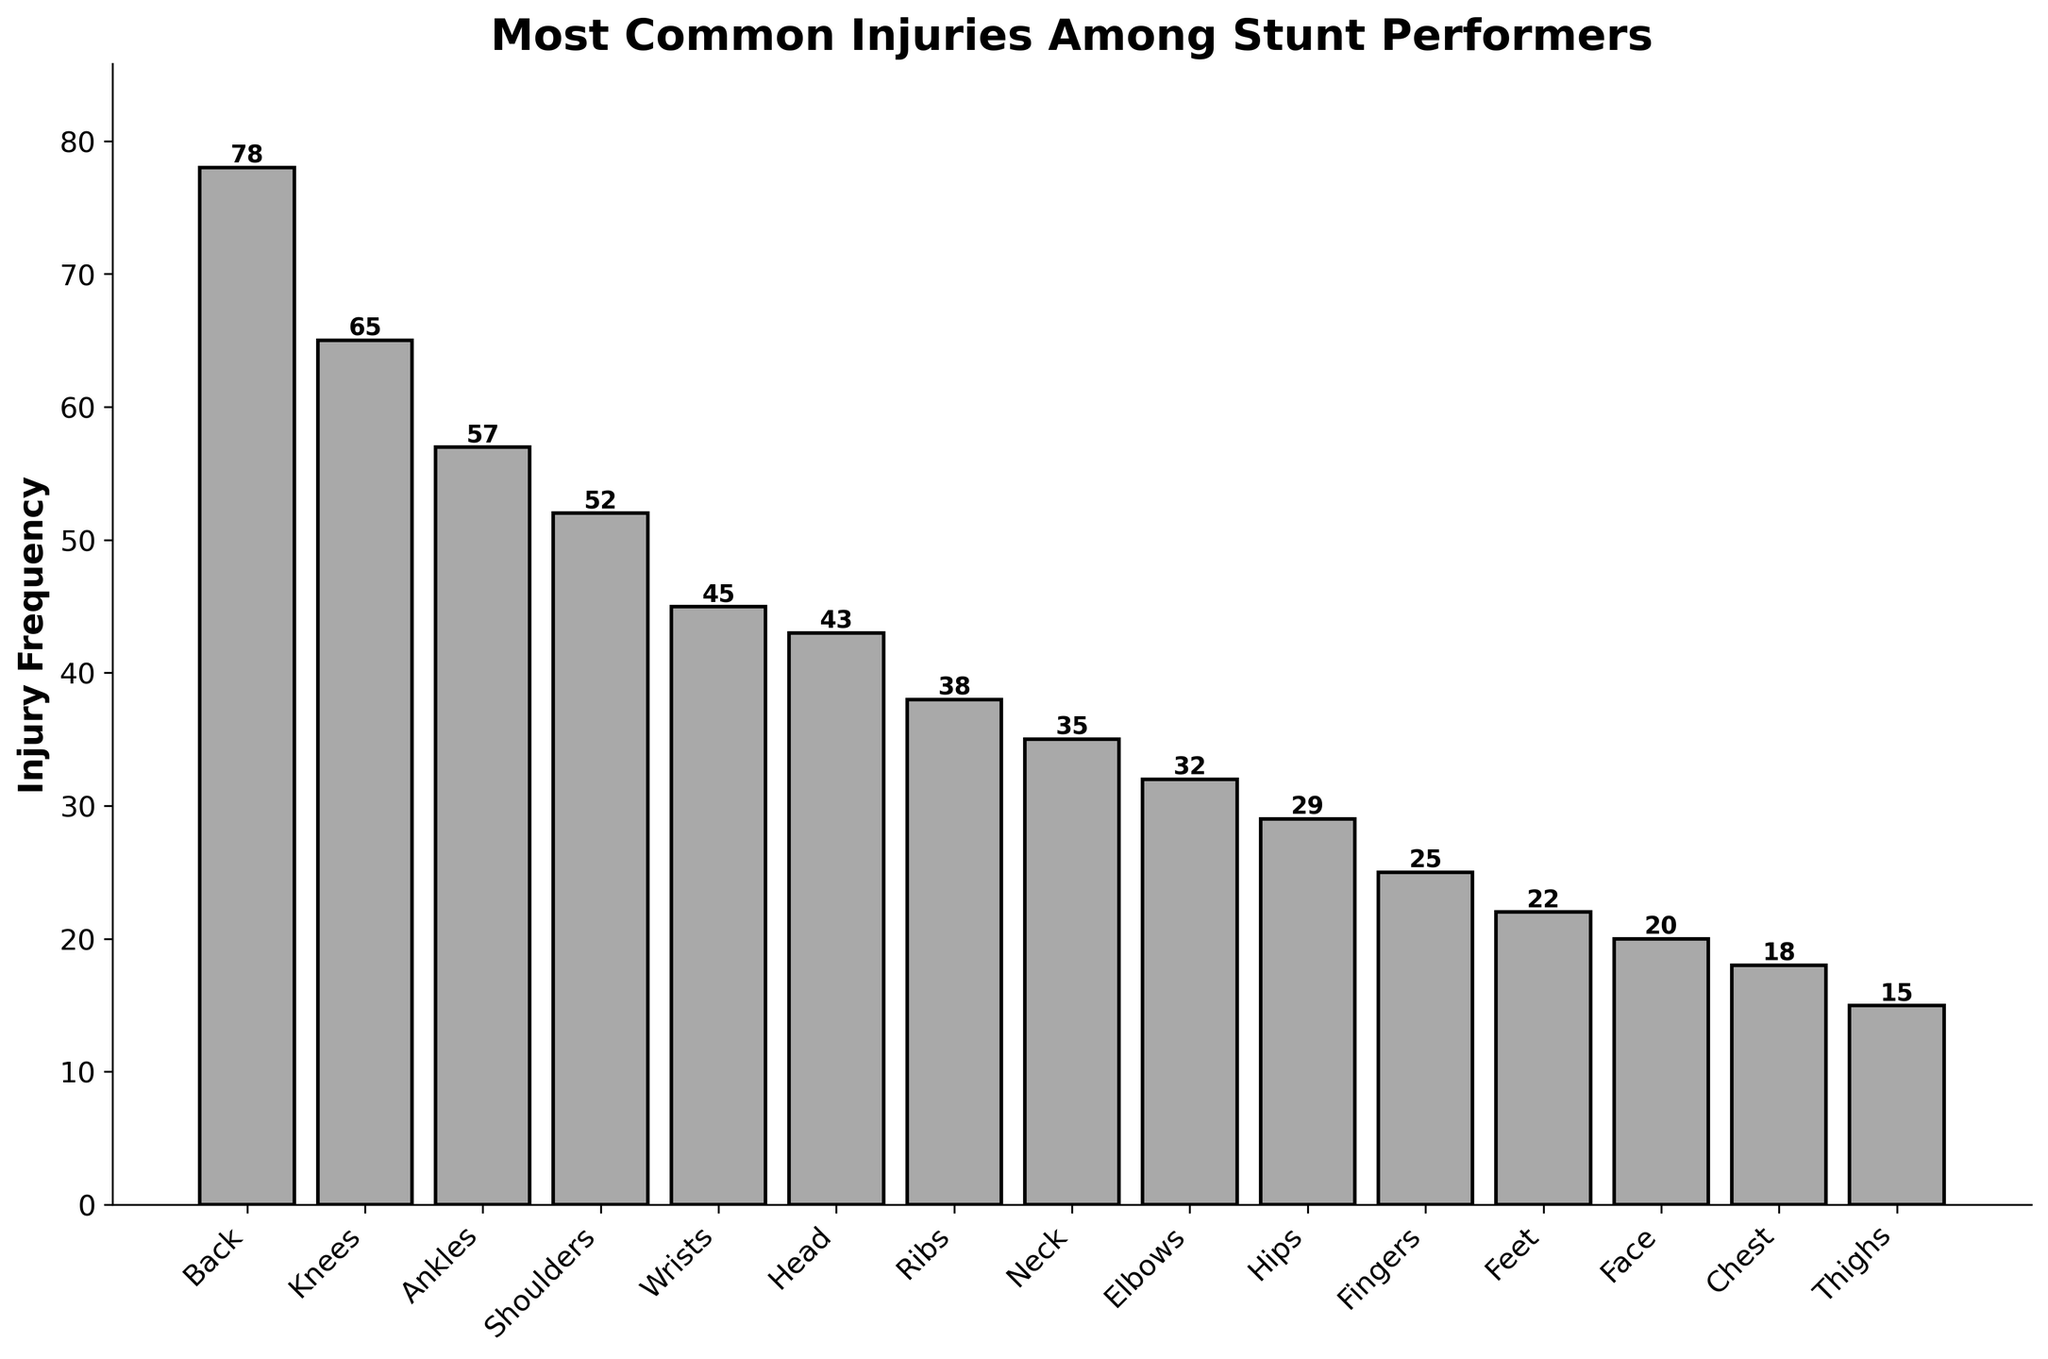What's the most common injury among stunt performers? By looking at the height of the bars, we can see that the bar for "Back" is the tallest. This indicates that it has the highest injury frequency compared to other body parts.
Answer: Back Which injury is more common: wrist or ankle injuries? By comparing the heights of the bars labeled "Wrists" and "Ankles," we can see that the bar for "Ankles" is taller than the bar for "Wrists." This indicates that ankle injuries are more frequent.
Answer: Ankle injuries What is the combined injury frequency for shoulders and elbows? Identify the heights of the bars for "Shoulders" (52) and "Elbows" (32). Adding these gives 52 + 32 = 84.
Answer: 84 How many injuries do the neck, ribs, and hips sum up to? The bar heights for "Neck," "Ribs," and "Hips" are 35, 38, and 29 respectively. Summing these values results in 35 + 38 + 29 = 102.
Answer: 102 Is the injury frequency for the feet greater than for the face? Compare the heights of the bars for "Feet" (22) and "Face" (20). The bar for "Feet" is taller than "Face," indicating a higher frequency of injuries for the feet.
Answer: Yes Which body part has more injuries: the chest or the face? Compare the bars for "Chest" (18) and "Face" (20). The "Face" bar is taller, indicating more injuries.
Answer: Face How many injuries are there in total for knees, ankles, and wrists combined? Heights for "Knees" (65), "Ankles" (57), and "Wrists" (45) are summed as 65 + 57 + 45 = 167.
Answer: 167 Compare the injury frequencies between the head and neck. Which is greater? The bar for "Head" shows 43 injuries while the bar for "Neck" shows 35. The head has more injuries.
Answer: Head What is the least common injury recorded in the chart? The shortest bar corresponds to "Thighs," with a frequency of 15, indicating the least common injury.
Answer: Thighs What is the difference in injury frequency between fingers and feet? Bar heights for "Fingers" and "Feet" are 25 and 22 respectively. The difference is 25 - 22 = 3.
Answer: 3 